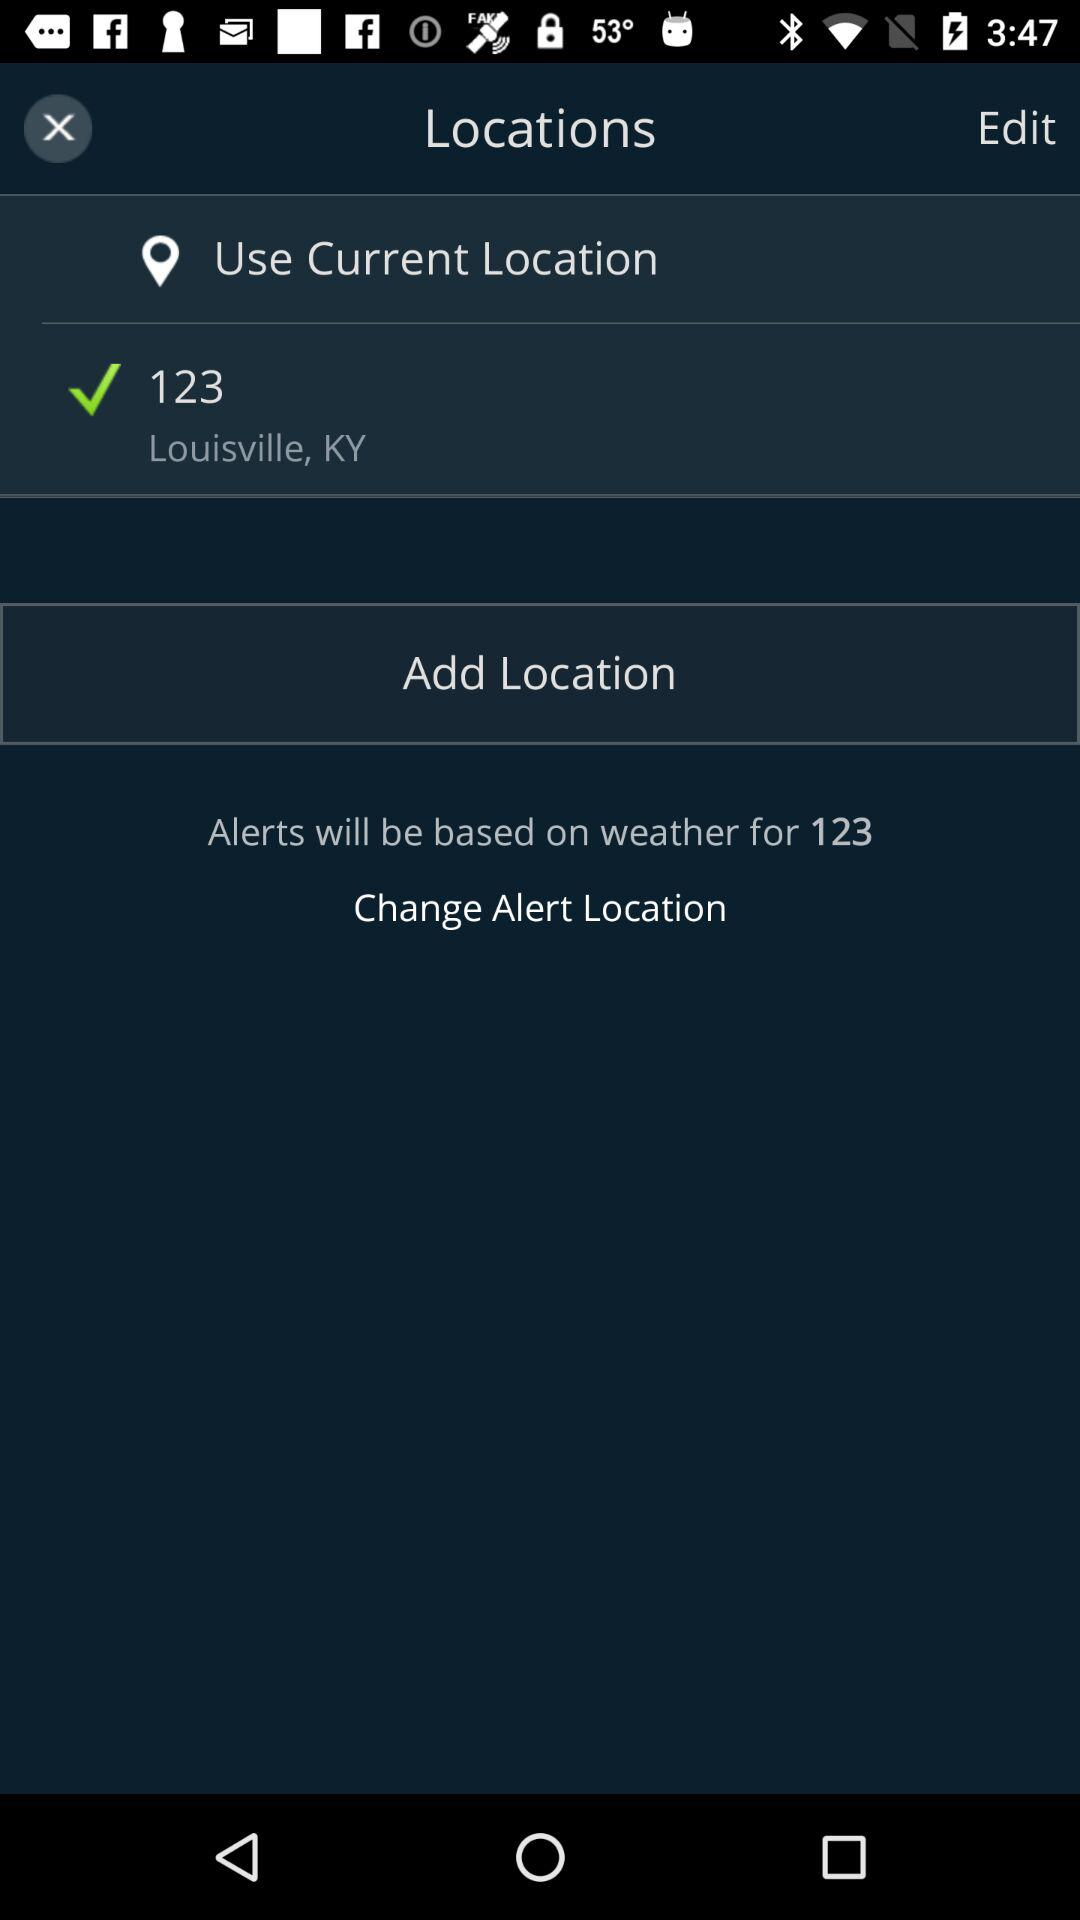How many locations are not current?
Answer the question using a single word or phrase. 1 